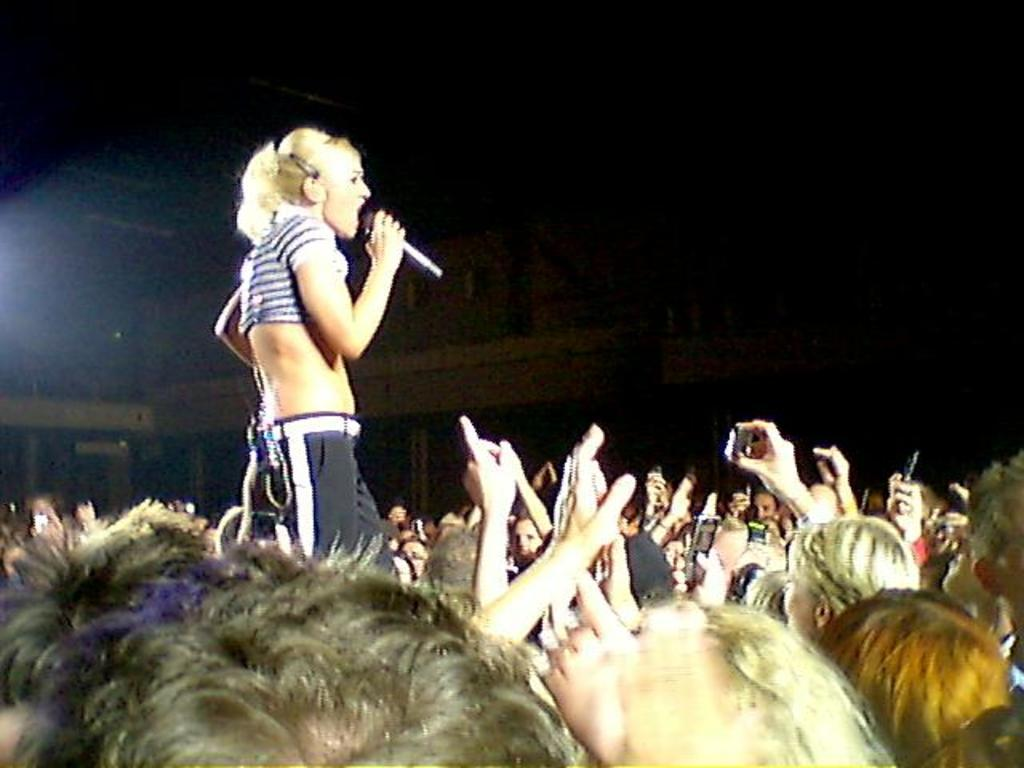How many people are in the image? There is a group of persons in the image. Can you describe the woman's position in the group? A woman is standing in the center of the group. What is the woman doing in the image? The woman is singing. What object is the woman holding in her hand? The woman is holding a microphone in her hand. What type of pie is being served to the group in the image? There is no pie present in the image; the woman is singing and holding a microphone. How many chances does the woman have to sing in the image? The image does not indicate a specific number of chances for the woman to sing; she is already singing in the image. 